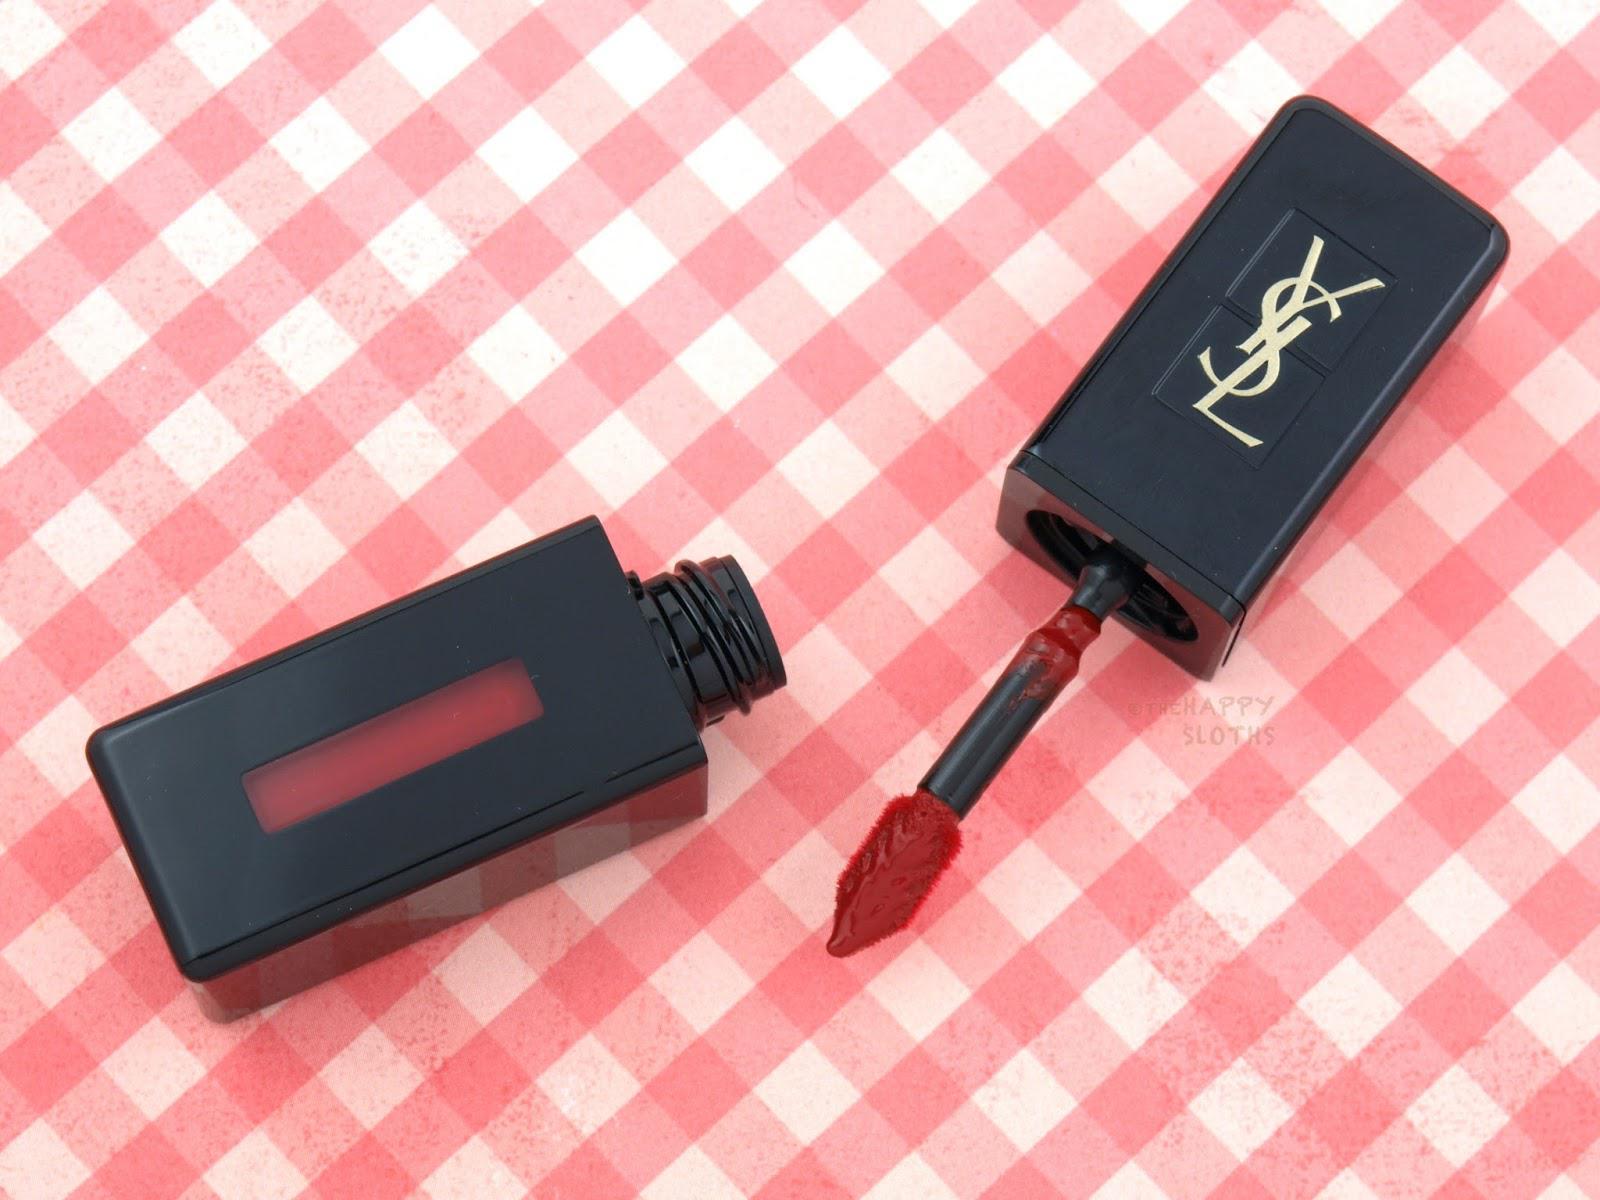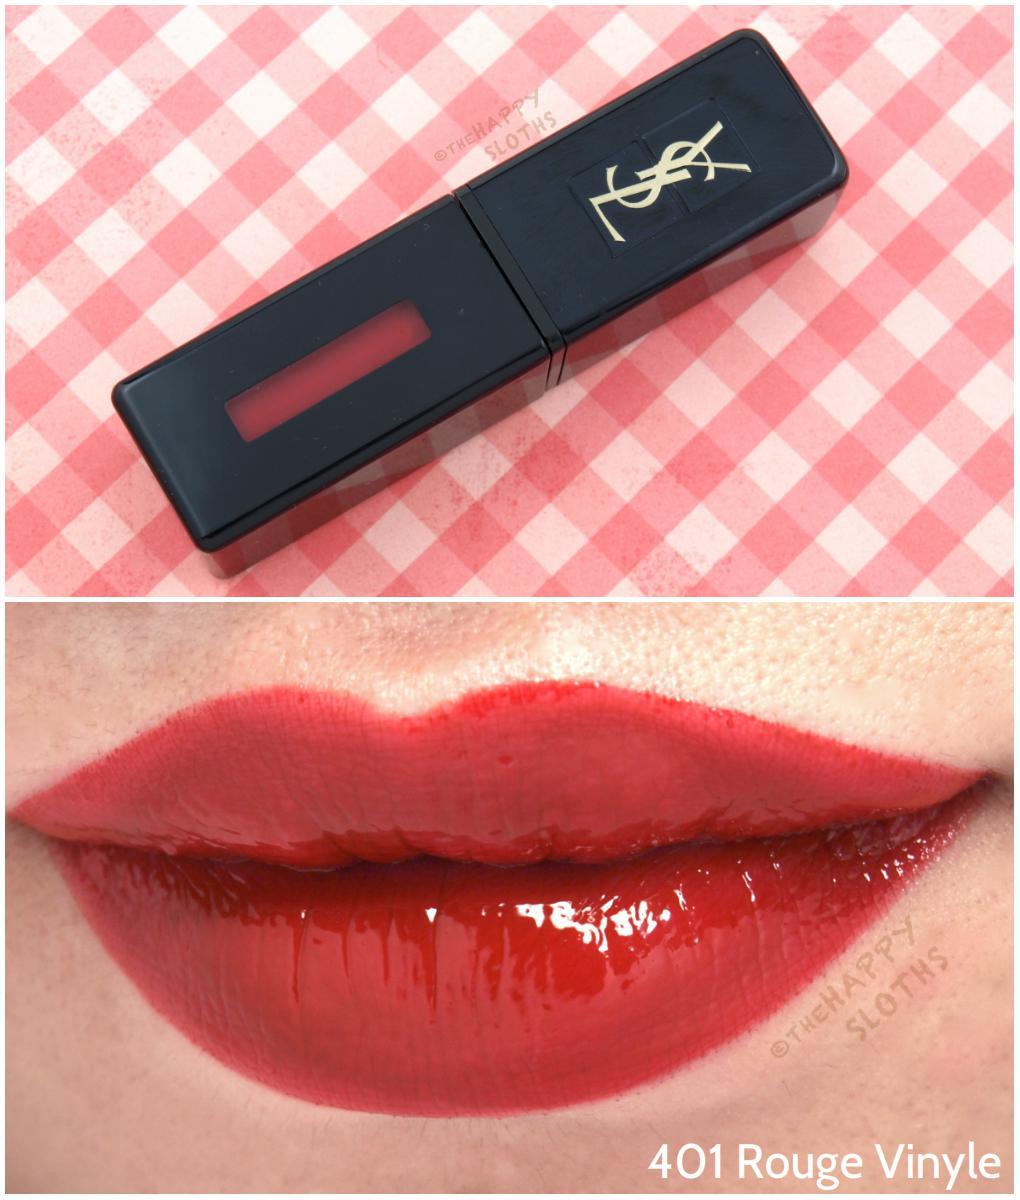The first image is the image on the left, the second image is the image on the right. Analyze the images presented: Is the assertion "In one image, a woman's lips are visible with lip makeup" valid? Answer yes or no. Yes. The first image is the image on the left, the second image is the image on the right. For the images shown, is this caption "A single set of lips is shown under a tube of lipstick in one of the images." true? Answer yes or no. Yes. 